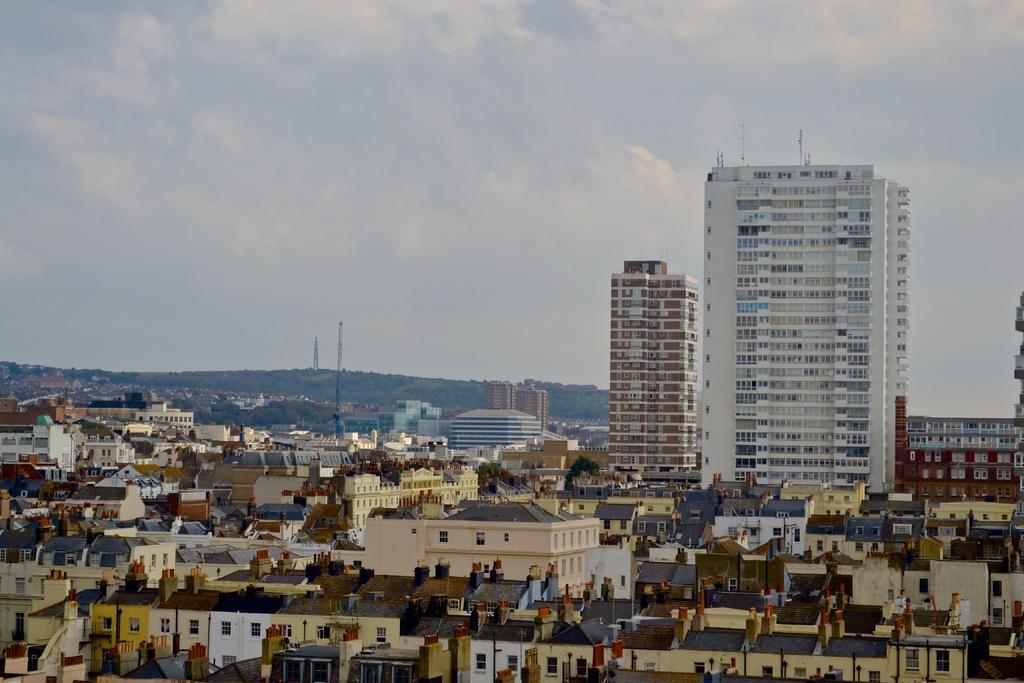Describe this image in one or two sentences. In this picture I can see number of buildings and I see 2 poles. In the background I can see the sky. 